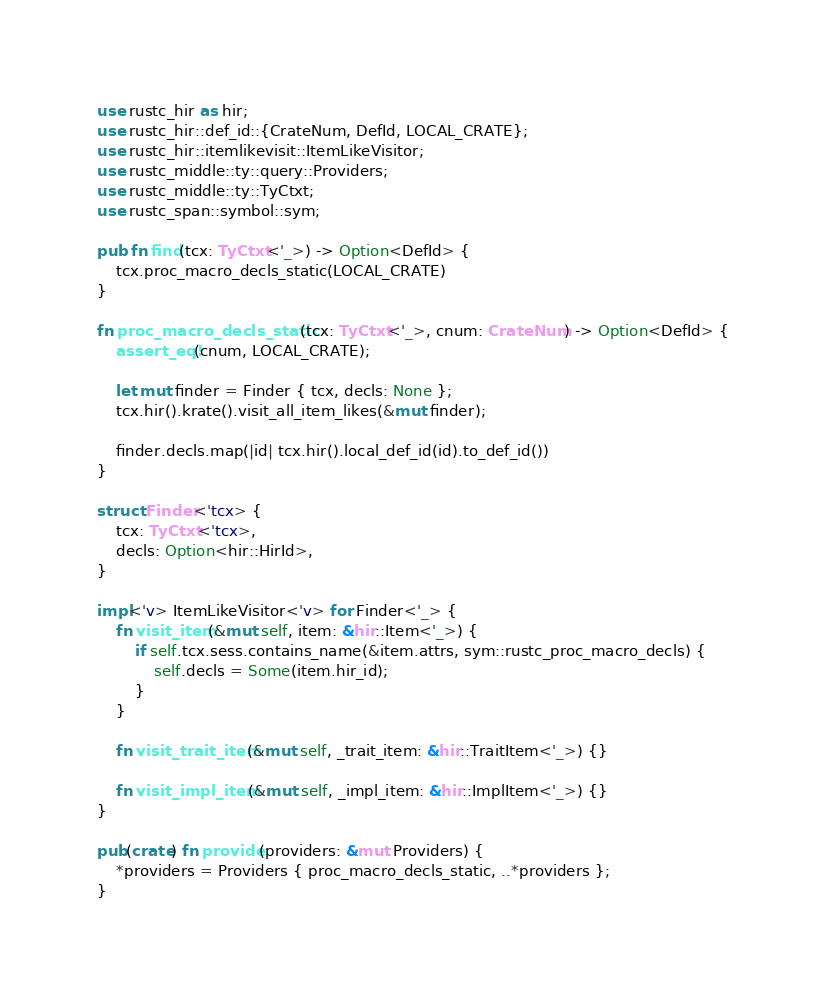<code> <loc_0><loc_0><loc_500><loc_500><_Rust_>use rustc_hir as hir;
use rustc_hir::def_id::{CrateNum, DefId, LOCAL_CRATE};
use rustc_hir::itemlikevisit::ItemLikeVisitor;
use rustc_middle::ty::query::Providers;
use rustc_middle::ty::TyCtxt;
use rustc_span::symbol::sym;

pub fn find(tcx: TyCtxt<'_>) -> Option<DefId> {
    tcx.proc_macro_decls_static(LOCAL_CRATE)
}

fn proc_macro_decls_static(tcx: TyCtxt<'_>, cnum: CrateNum) -> Option<DefId> {
    assert_eq!(cnum, LOCAL_CRATE);

    let mut finder = Finder { tcx, decls: None };
    tcx.hir().krate().visit_all_item_likes(&mut finder);

    finder.decls.map(|id| tcx.hir().local_def_id(id).to_def_id())
}

struct Finder<'tcx> {
    tcx: TyCtxt<'tcx>,
    decls: Option<hir::HirId>,
}

impl<'v> ItemLikeVisitor<'v> for Finder<'_> {
    fn visit_item(&mut self, item: &hir::Item<'_>) {
        if self.tcx.sess.contains_name(&item.attrs, sym::rustc_proc_macro_decls) {
            self.decls = Some(item.hir_id);
        }
    }

    fn visit_trait_item(&mut self, _trait_item: &hir::TraitItem<'_>) {}

    fn visit_impl_item(&mut self, _impl_item: &hir::ImplItem<'_>) {}
}

pub(crate) fn provide(providers: &mut Providers) {
    *providers = Providers { proc_macro_decls_static, ..*providers };
}
</code> 